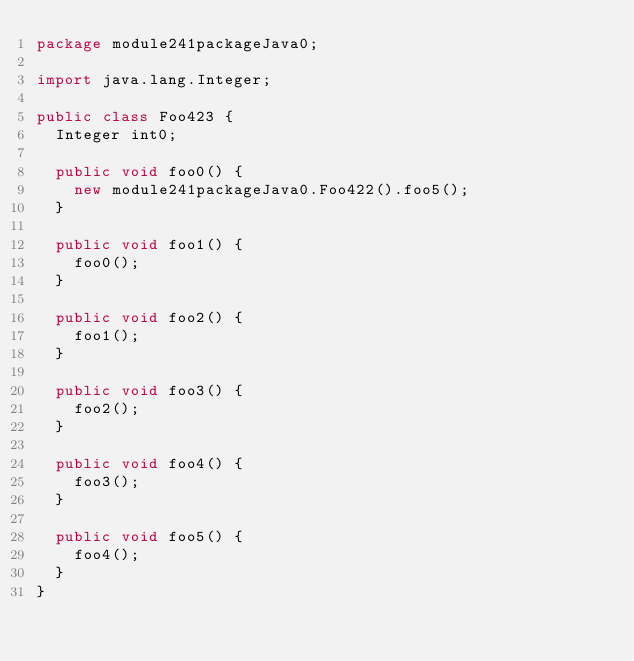<code> <loc_0><loc_0><loc_500><loc_500><_Java_>package module241packageJava0;

import java.lang.Integer;

public class Foo423 {
  Integer int0;

  public void foo0() {
    new module241packageJava0.Foo422().foo5();
  }

  public void foo1() {
    foo0();
  }

  public void foo2() {
    foo1();
  }

  public void foo3() {
    foo2();
  }

  public void foo4() {
    foo3();
  }

  public void foo5() {
    foo4();
  }
}
</code> 